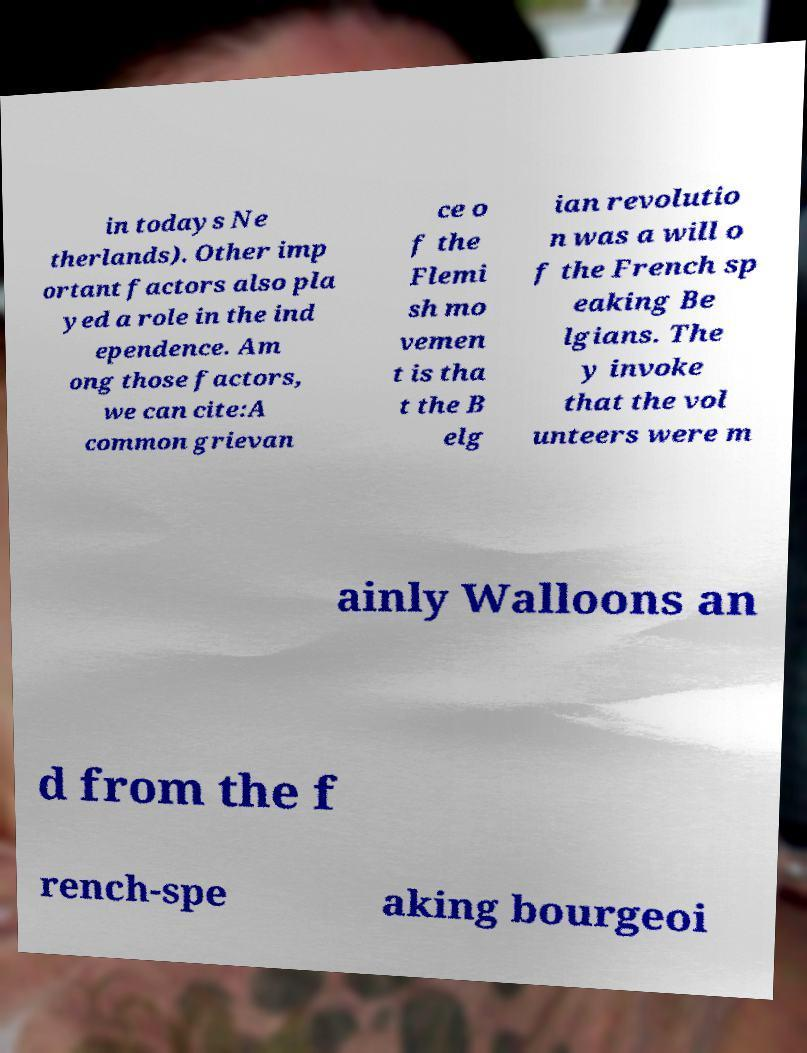Can you accurately transcribe the text from the provided image for me? in todays Ne therlands). Other imp ortant factors also pla yed a role in the ind ependence. Am ong those factors, we can cite:A common grievan ce o f the Flemi sh mo vemen t is tha t the B elg ian revolutio n was a will o f the French sp eaking Be lgians. The y invoke that the vol unteers were m ainly Walloons an d from the f rench-spe aking bourgeoi 